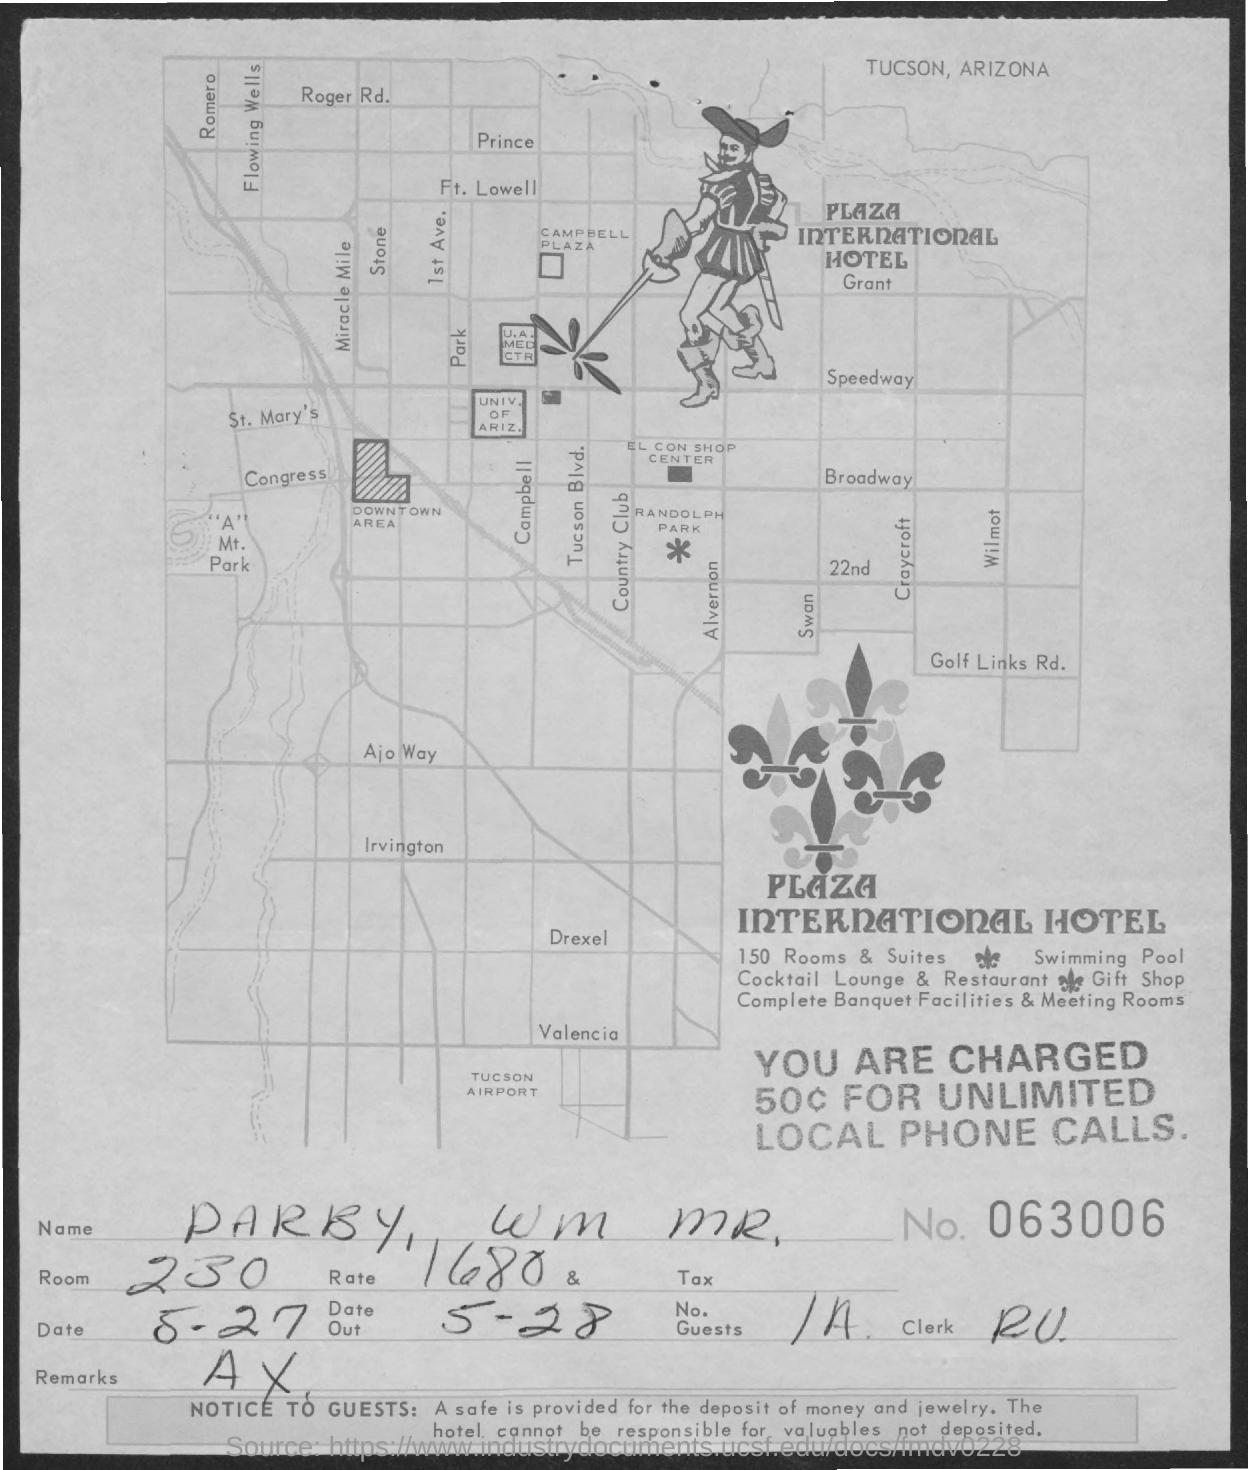List a handful of essential elements in this visual. The name of the hotel is the Plaza International Hotel. The room number is 230 The document number is 063006... 